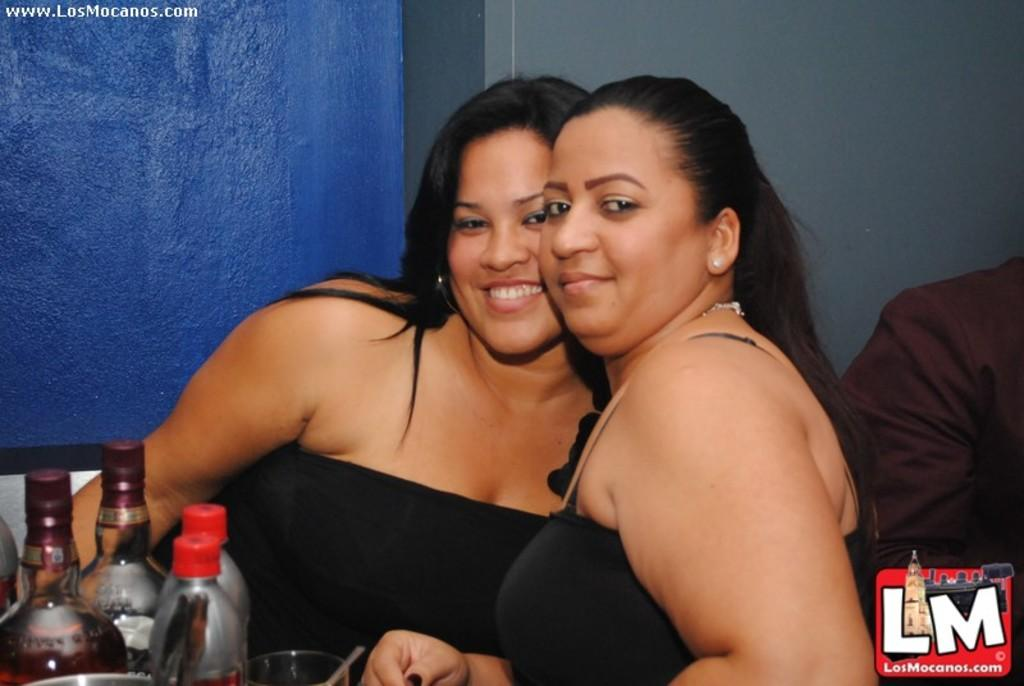Who can be seen in the center of the picture? There are two women in the center of the picture. What objects are on the left side of the picture? There are bottles on the left side of the picture. What is present on the right side of the picture? There is a logo and a person on the right side of the picture. What can be seen in the background of the picture? There is a well in the background of the picture. What type of yam is being used as a lamp in the image? There is no yam or lamp present in the image. What kind of marble is visible in the image? There is no marble visible in the image. 